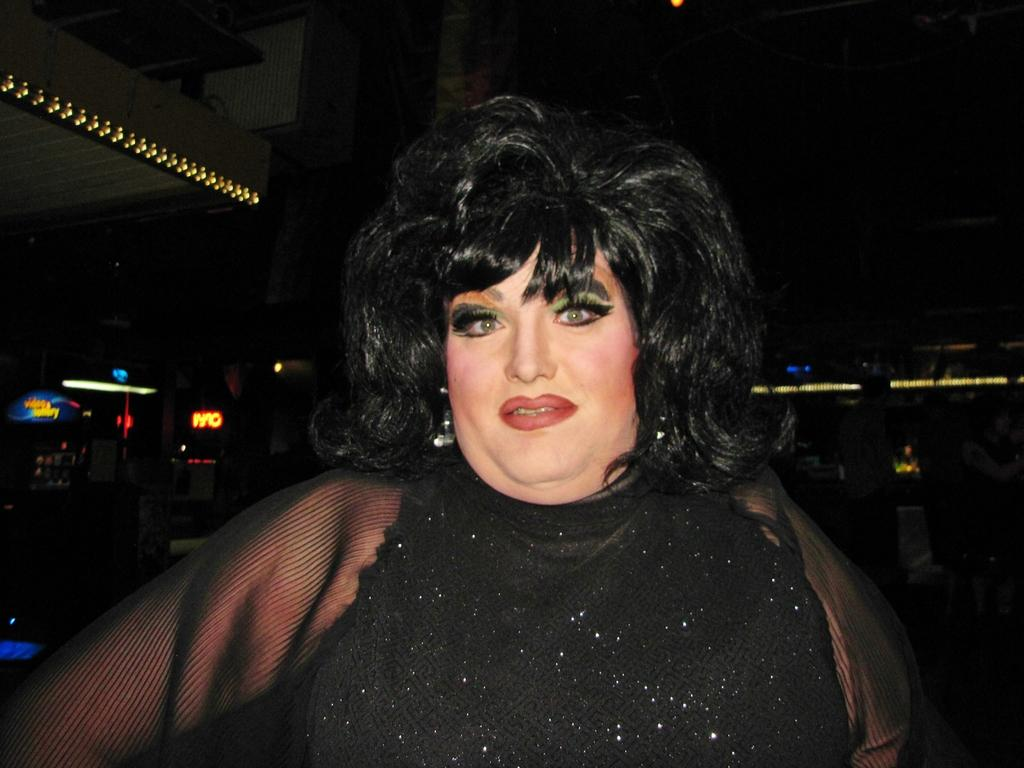Who is the main subject in the image? There is a woman in the image. What is the woman wearing? The woman is wearing a black dress. What is special about the dress? The dress appears to be shining. What can be seen in the background of the image? There are lights visible in the background of the image, and the background is dark. What language is the woman speaking in the image? The image does not provide any information about the woman speaking or any language being spoken. --- Facts: 1. There is a car in the image. 2. The car is red. 3. The car has four wheels. 4. There are people in the car. 5. The car is parked on the street. Absurd Topics: bird, ocean, mountain Conversation: What is the main subject in the image? There is a car in the image. What color is the car? The car is red. How many wheels does the car have? The car has four wheels. Are there any passengers in the car? Yes, there are people in the car. Where is the car located in the image? The car is parked on the street. Reasoning: Let's think step by step in order to produce the conversation. We start by identifying the main subject in the image, which is the car. Then, we describe the car's color and number of wheels. Next, we mention the presence of passengers and their location within the car. Finally, we describe the car's location in the image, which is parked on the street. Each question is designed to elicit a specific detail about the image that is known from the provided facts. Absurd Question/Answer: Can you see any mountains in the background of the image? There is no mention of mountains in the image; it only features a red car parked on the street with people inside. 